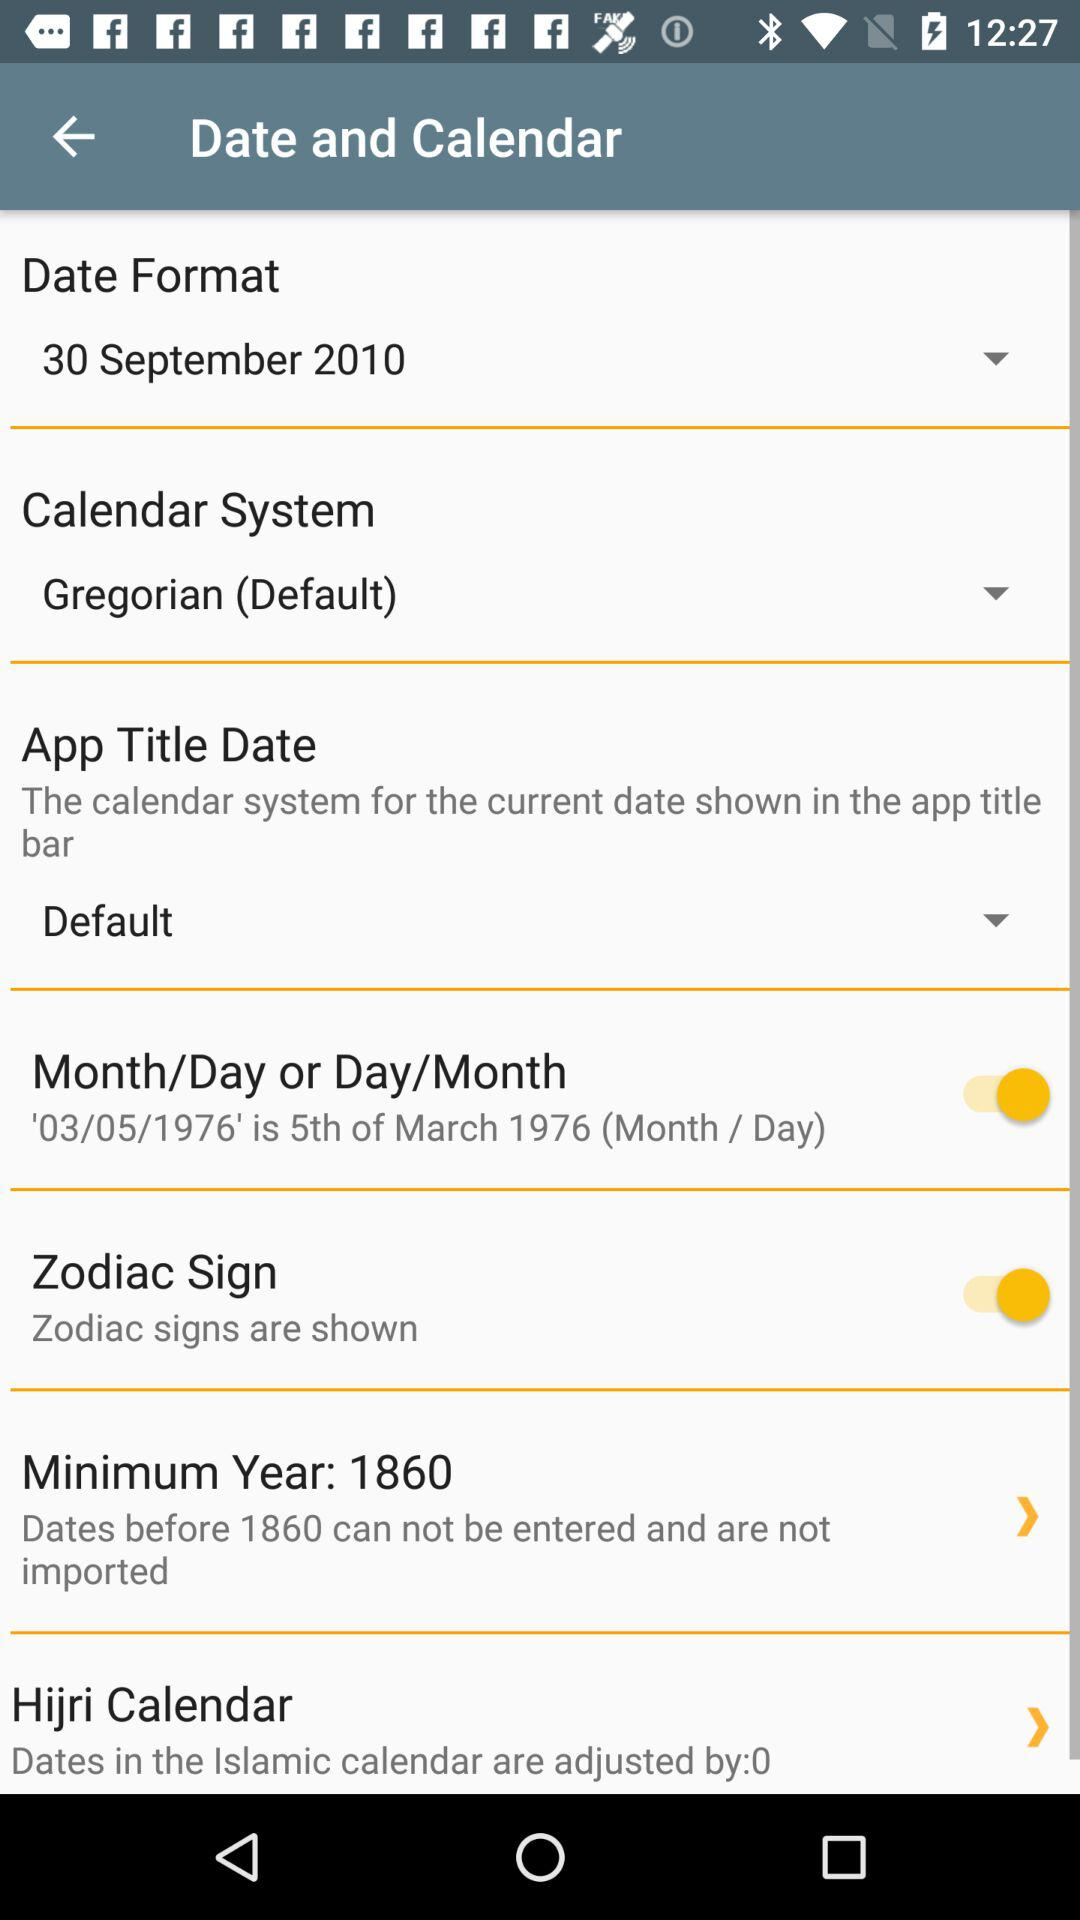What is the month shown in the screenshot in "Date Format"? The month is September. 